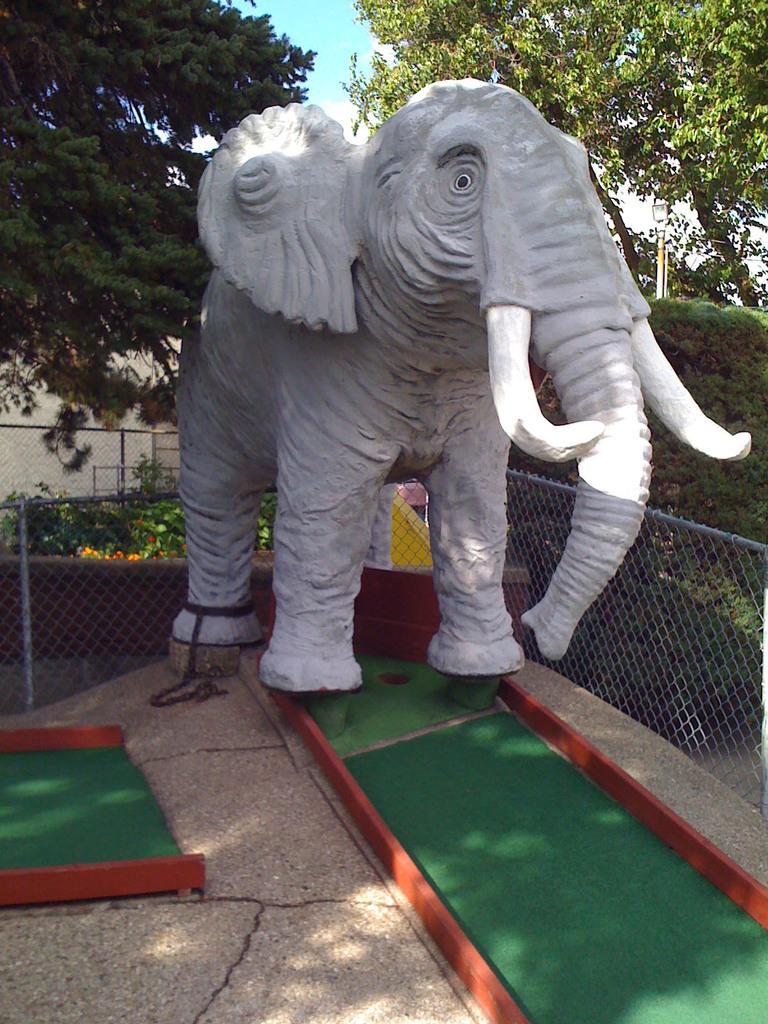Can you describe this image briefly? In this image we can see a statue of an elephant and some trees. 